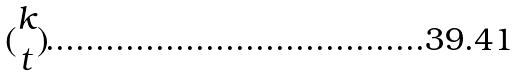<formula> <loc_0><loc_0><loc_500><loc_500>( \begin{matrix} k \\ t \end{matrix} )</formula> 